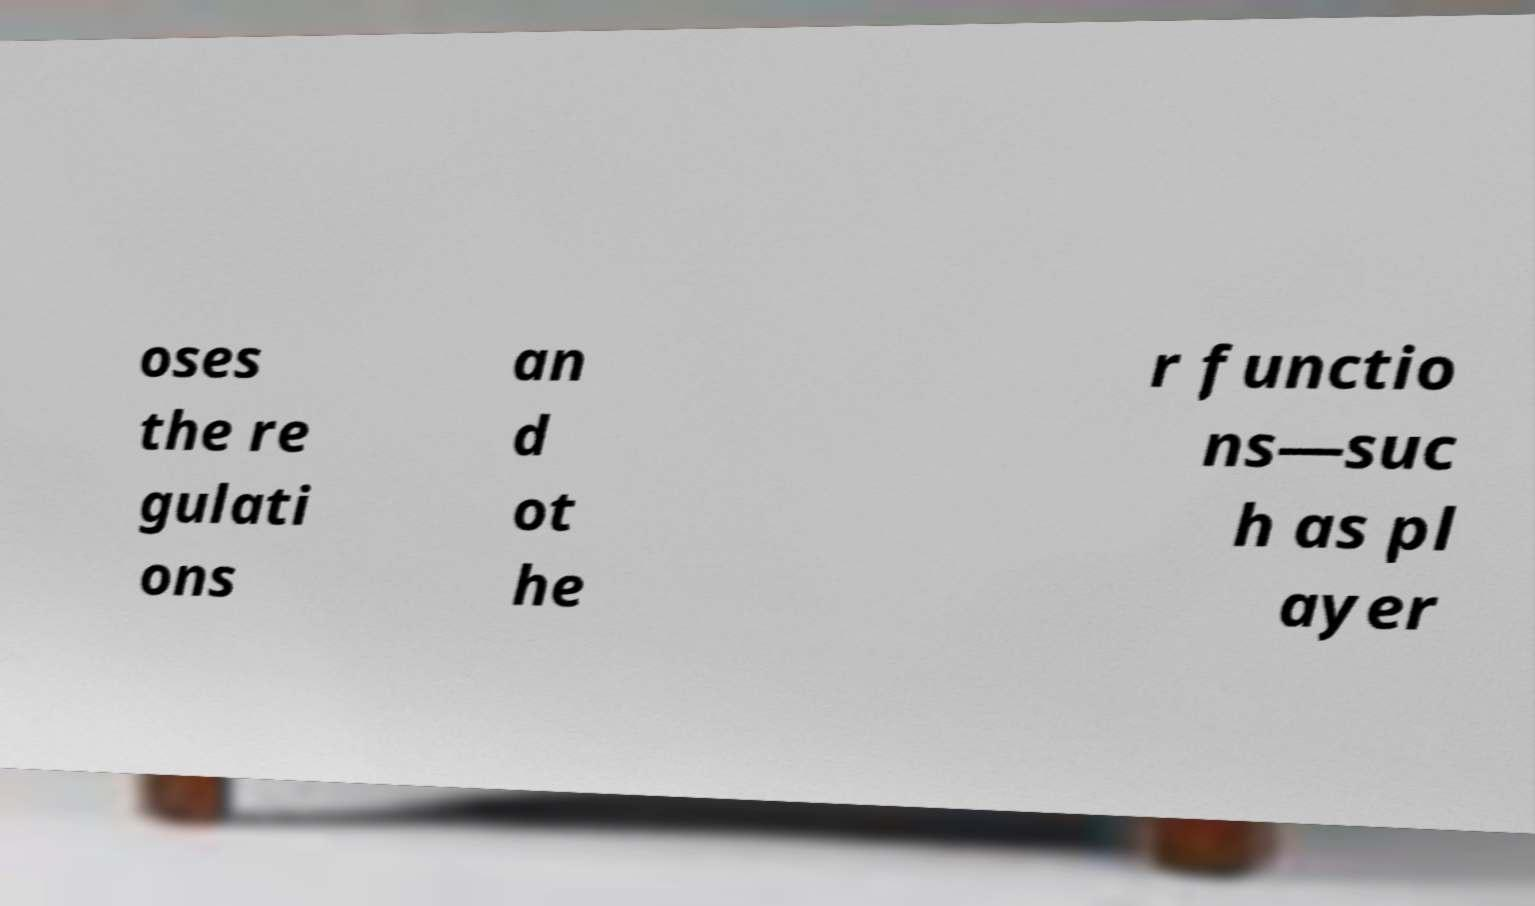What messages or text are displayed in this image? I need them in a readable, typed format. oses the re gulati ons an d ot he r functio ns—suc h as pl ayer 